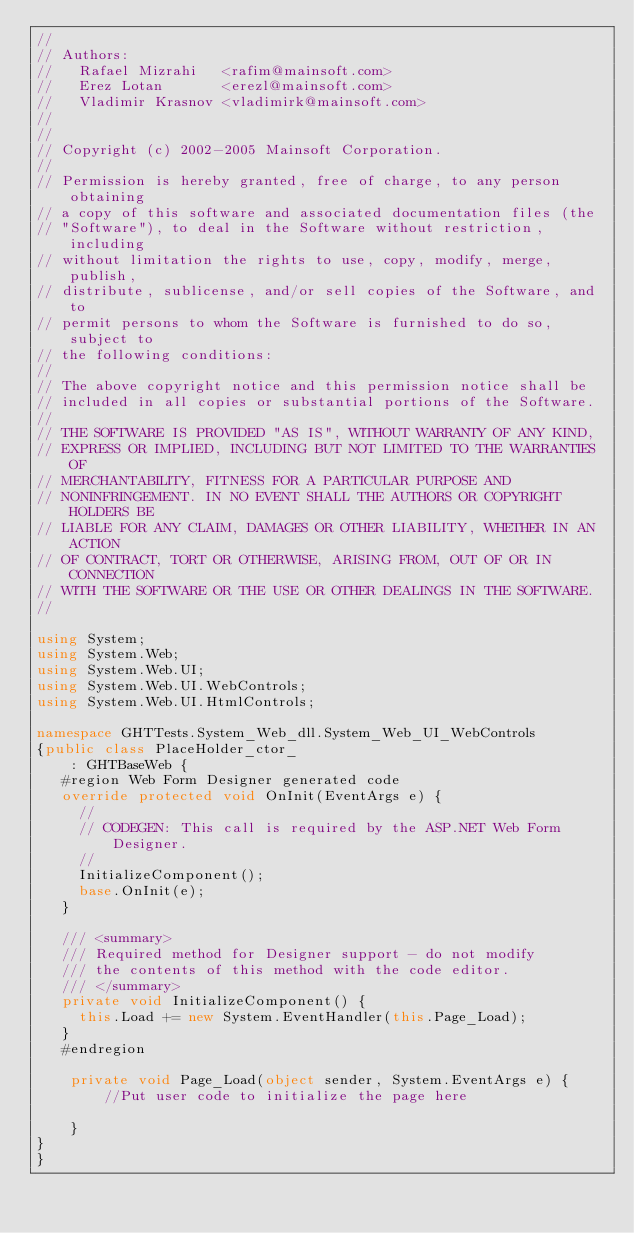Convert code to text. <code><loc_0><loc_0><loc_500><loc_500><_C#_>//
// Authors:
//   Rafael Mizrahi   <rafim@mainsoft.com>
//   Erez Lotan       <erezl@mainsoft.com>
//   Vladimir Krasnov <vladimirk@mainsoft.com>
//
//
// Copyright (c) 2002-2005 Mainsoft Corporation.
//
// Permission is hereby granted, free of charge, to any person obtaining
// a copy of this software and associated documentation files (the
// "Software"), to deal in the Software without restriction, including
// without limitation the rights to use, copy, modify, merge, publish,
// distribute, sublicense, and/or sell copies of the Software, and to
// permit persons to whom the Software is furnished to do so, subject to
// the following conditions:
//
// The above copyright notice and this permission notice shall be
// included in all copies or substantial portions of the Software.
//
// THE SOFTWARE IS PROVIDED "AS IS", WITHOUT WARRANTY OF ANY KIND,
// EXPRESS OR IMPLIED, INCLUDING BUT NOT LIMITED TO THE WARRANTIES OF
// MERCHANTABILITY, FITNESS FOR A PARTICULAR PURPOSE AND
// NONINFRINGEMENT. IN NO EVENT SHALL THE AUTHORS OR COPYRIGHT HOLDERS BE
// LIABLE FOR ANY CLAIM, DAMAGES OR OTHER LIABILITY, WHETHER IN AN ACTION
// OF CONTRACT, TORT OR OTHERWISE, ARISING FROM, OUT OF OR IN CONNECTION
// WITH THE SOFTWARE OR THE USE OR OTHER DEALINGS IN THE SOFTWARE.
//

using System;
using System.Web;
using System.Web.UI;
using System.Web.UI.WebControls;
using System.Web.UI.HtmlControls;

namespace GHTTests.System_Web_dll.System_Web_UI_WebControls
{public class PlaceHolder_ctor_
    : GHTBaseWeb {
	 #region Web Form Designer generated code
	 override protected void OnInit(EventArgs e) {
		 //
		 // CODEGEN: This call is required by the ASP.NET Web Form Designer.
		 //
		 InitializeComponent();
		 base.OnInit(e);
	 }
		
	 /// <summary>
	 /// Required method for Designer support - do not modify
	 /// the contents of this method with the code editor.
	 /// </summary>
	 private void InitializeComponent() {    
		 this.Load += new System.EventHandler(this.Page_Load);
	 }
	 #endregion

    private void Page_Load(object sender, System.EventArgs e) {
        //Put user code to initialize the page here

    }
}
}
</code> 